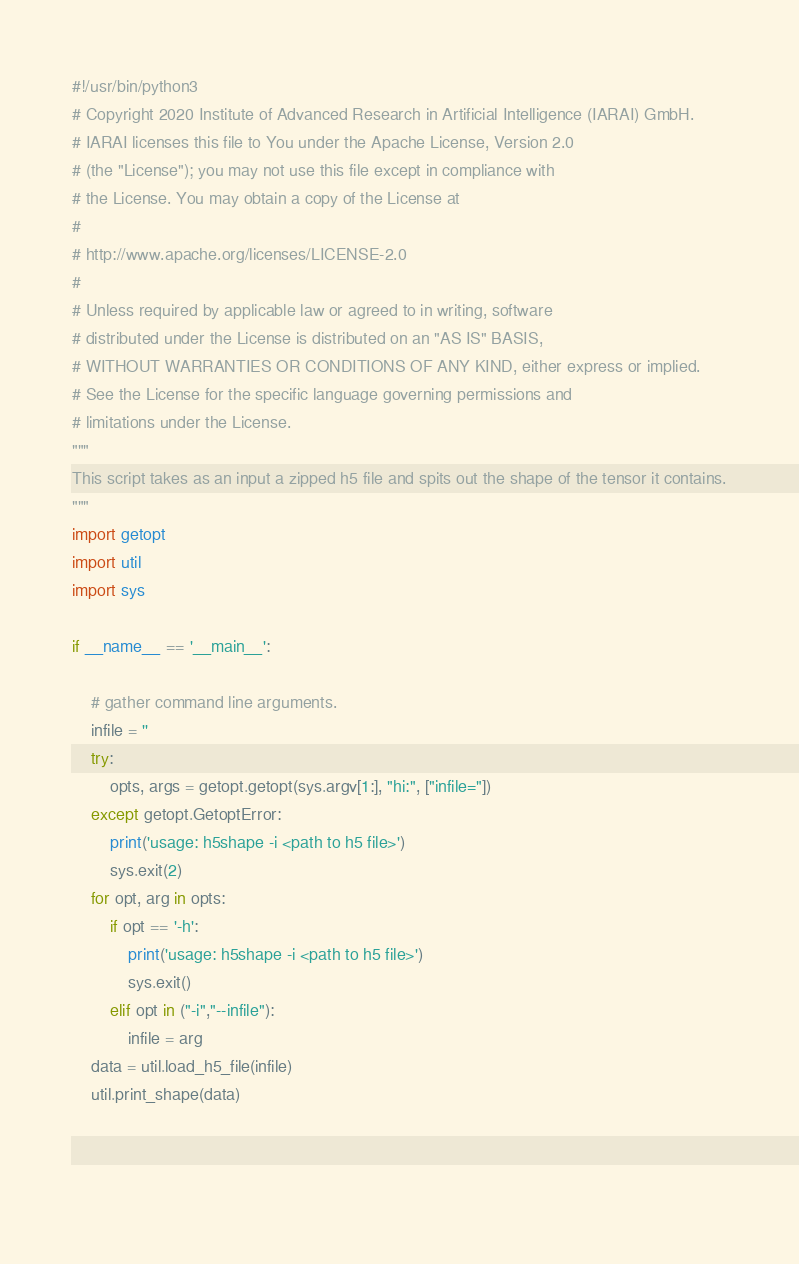<code> <loc_0><loc_0><loc_500><loc_500><_Python_>#!/usr/bin/python3
# Copyright 2020 Institute of Advanced Research in Artificial Intelligence (IARAI) GmbH.
# IARAI licenses this file to You under the Apache License, Version 2.0
# (the "License"); you may not use this file except in compliance with
# the License. You may obtain a copy of the License at
#
# http://www.apache.org/licenses/LICENSE-2.0
#
# Unless required by applicable law or agreed to in writing, software
# distributed under the License is distributed on an "AS IS" BASIS,
# WITHOUT WARRANTIES OR CONDITIONS OF ANY KIND, either express or implied.
# See the License for the specific language governing permissions and
# limitations under the License.
"""
This script takes as an input a zipped h5 file and spits out the shape of the tensor it contains.
"""
import getopt
import util
import sys

if __name__ == '__main__':

    # gather command line arguments.
    infile = ''
    try:
        opts, args = getopt.getopt(sys.argv[1:], "hi:", ["infile="])
    except getopt.GetoptError:
        print('usage: h5shape -i <path to h5 file>')
        sys.exit(2)
    for opt, arg in opts:
        if opt == '-h':
            print('usage: h5shape -i <path to h5 file>')
            sys.exit()
        elif opt in ("-i","--infile"):
            infile = arg
    data = util.load_h5_file(infile)
    util.print_shape(data)

            
            
</code> 